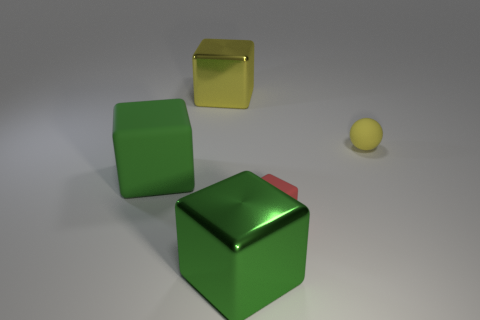The yellow object in front of the metallic object behind the matte cube to the left of the red block is what shape?
Provide a short and direct response. Sphere. What is the material of the big thing on the right side of the big yellow shiny block behind the tiny red rubber block?
Your response must be concise. Metal. There is a large green thing that is made of the same material as the red cube; what shape is it?
Your answer should be compact. Cube. Are there any other things that are the same shape as the big matte thing?
Offer a terse response. Yes. How many yellow things are right of the tiny cube?
Ensure brevity in your answer.  1. Are there any metal objects?
Provide a succinct answer. Yes. The metal object that is behind the yellow object that is right of the big metal thing in front of the rubber sphere is what color?
Provide a short and direct response. Yellow. Are there any spheres in front of the large green object on the left side of the big yellow object?
Ensure brevity in your answer.  No. Does the shiny block on the left side of the green shiny object have the same color as the large metallic block that is in front of the large rubber cube?
Ensure brevity in your answer.  No. How many brown metallic cylinders are the same size as the yellow matte sphere?
Provide a succinct answer. 0. 